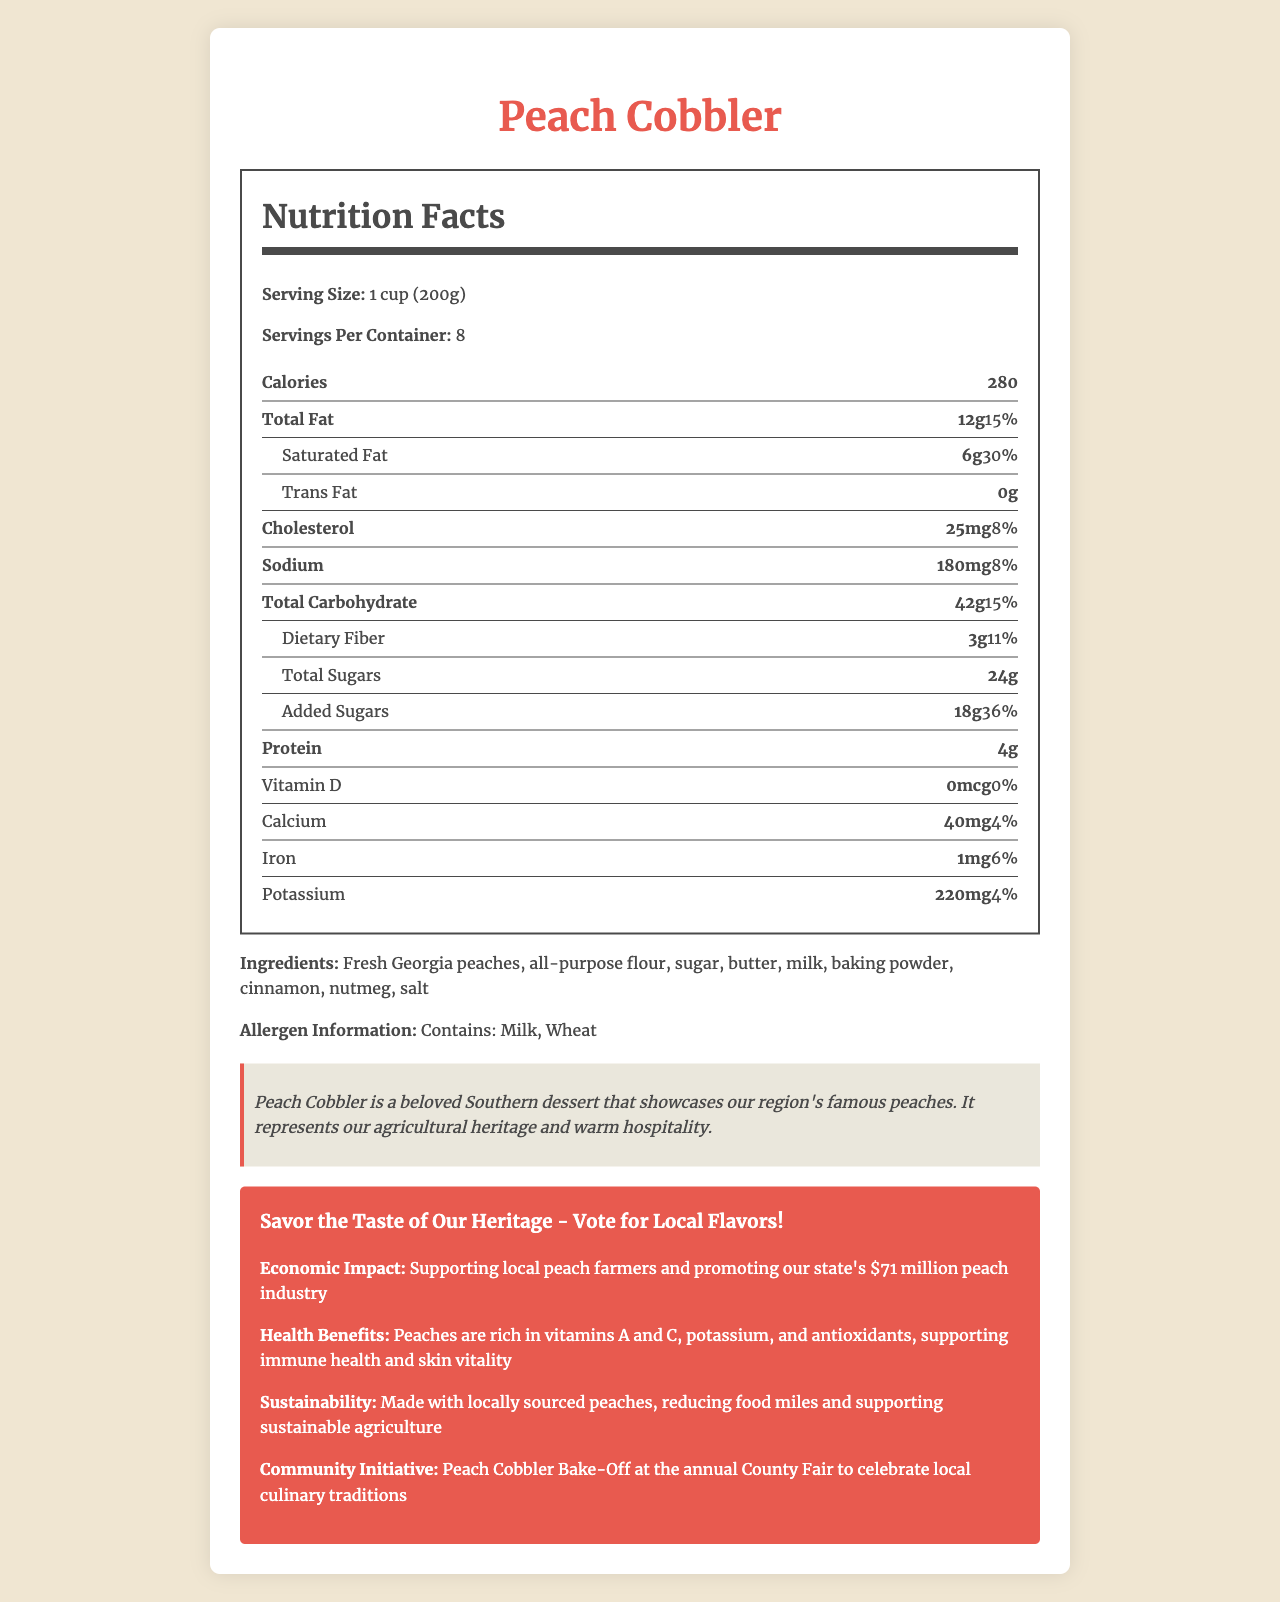what is the serving size of Peach Cobbler? The serving size information is stated clearly in the document as "1 cup (200g)".
Answer: 1 cup (200g) how many servings are in one container? The document mentions "Servings Per Container" as 8.
Answer: 8 servings how many calories are in one serving of Peach Cobbler? The document specifies that each serving contains 280 calories.
Answer: 280 calories what is the total amount of fat per serving? The total fat amount per serving is indicated as 12g in the document.
Answer: 12g what allergens are present in Peach Cobbler? The allergen information section lists Milk and Wheat as potential allergens.
Answer: Milk, Wheat how much added sugar is there per serving? The document indicates that the amount of added sugars per serving is 18g.
Answer: 18g what is the amount of protein in one serving? The document indicates that each serving contains 4 grams of protein.
Answer: 4g where do the peaches in Peach Cobbler come from? The ingredients section mentions "Fresh Georgia peaches".
Answer: Georgia which of the following items have the lowest daily value percentage in Peach Cobbler? A. Total Fat B. Calcium C. Potassium The daily value percentages are 15% for Total Fat, 4% for Calcium, and 4% for Potassium, with Calcium having the lowest daily value percentage.
Answer: B. Calcium which nutrient in Peach Cobbler supports immune health and skin vitality? A. Vitamin A B. Vitamin D C. Antioxidants The document mentions that peaches, the primary ingredient, are rich in antioxidants, which support immune health and skin vitality.
Answer: C. Antioxidants is there any trans fat in Peach Cobbler? The document explicitly mentions that there is 0g of trans fat per serving.
Answer: No does Peach Cobbler have a direct impact on the local peach industry? The document states that Peach Cobbler supports local peach farmers and promotes the $71 million peach industry in the state.
Answer: Yes describe the main idea of the document The document is designed to inform readers about the nutritional content and health benefits of Peach Cobbler while promoting local culture and supporting the regional peach industry.
Answer: The document provides a detailed Nutrition Facts label for Peach Cobbler, highlighting its nutritional information, ingredients, allergens, cultural and economic significance, health benefits, sustainability aspects, and community initiatives. how many grams of dietary fiber does each serving contain? The document clearly indicates that each serving contains 3 grams of dietary fiber.
Answer: 3g what is the cultural significance of Peach Cobbler? The cultural note in the document elaborates on the importance of Peach Cobbler in Southern culture and its representation of the region's agricultural heritage.
Answer: Peach Cobbler is a beloved Southern dessert that showcases the region's famous peaches and represents agricultural heritage and warm hospitality. which of the following ingredients is not present in Peach Cobbler? A. Butter B. Vanilla Extract C. Cinnamon Vanilla Extract is not listed among the ingredients; while Butter and Cinnamon are.
Answer: B. Vanilla Extract what is the campaign slogan mentioned in the document? The campaign slogan is given in the campaign-info section of the document.
Answer: Savor the Taste of Our Heritage - Vote for Local Flavors! what type of community initiative is associated with Peach Cobbler? The document mentions a community initiative of a Peach Cobbler Bake-Off to celebrate local culinary traditions.
Answer: Peach Cobbler Bake-Off at the annual County Fair what vitamin is completely absent from Peach Cobbler? The document states that there is 0 mcg of Vitamin D in Peach Cobbler.
Answer: Vitamin D how much calcium is in one serving? The document indicates that each serving contains 40mg of calcium.
Answer: 40mg who is the manufacturer of the Peach Cobbler? The document does not provide any information regarding the manufacturer of Peach Cobbler.
Answer: Cannot be determined 